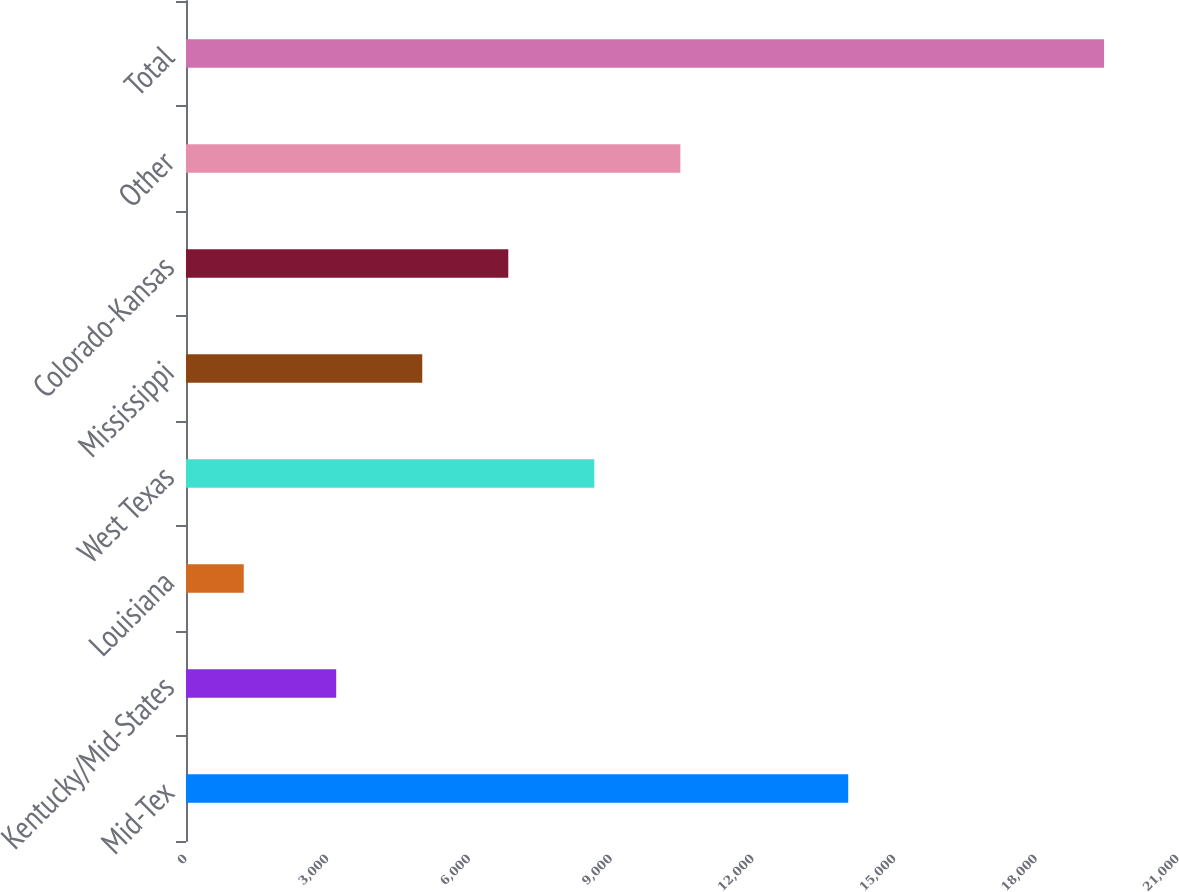Convert chart to OTSL. <chart><loc_0><loc_0><loc_500><loc_500><bar_chart><fcel>Mid-Tex<fcel>Kentucky/Mid-States<fcel>Louisiana<fcel>West Texas<fcel>Mississippi<fcel>Colorado-Kansas<fcel>Other<fcel>Total<nl><fcel>14019<fcel>3180<fcel>1222<fcel>8643.9<fcel>5001.3<fcel>6822.6<fcel>10465.2<fcel>19435<nl></chart> 